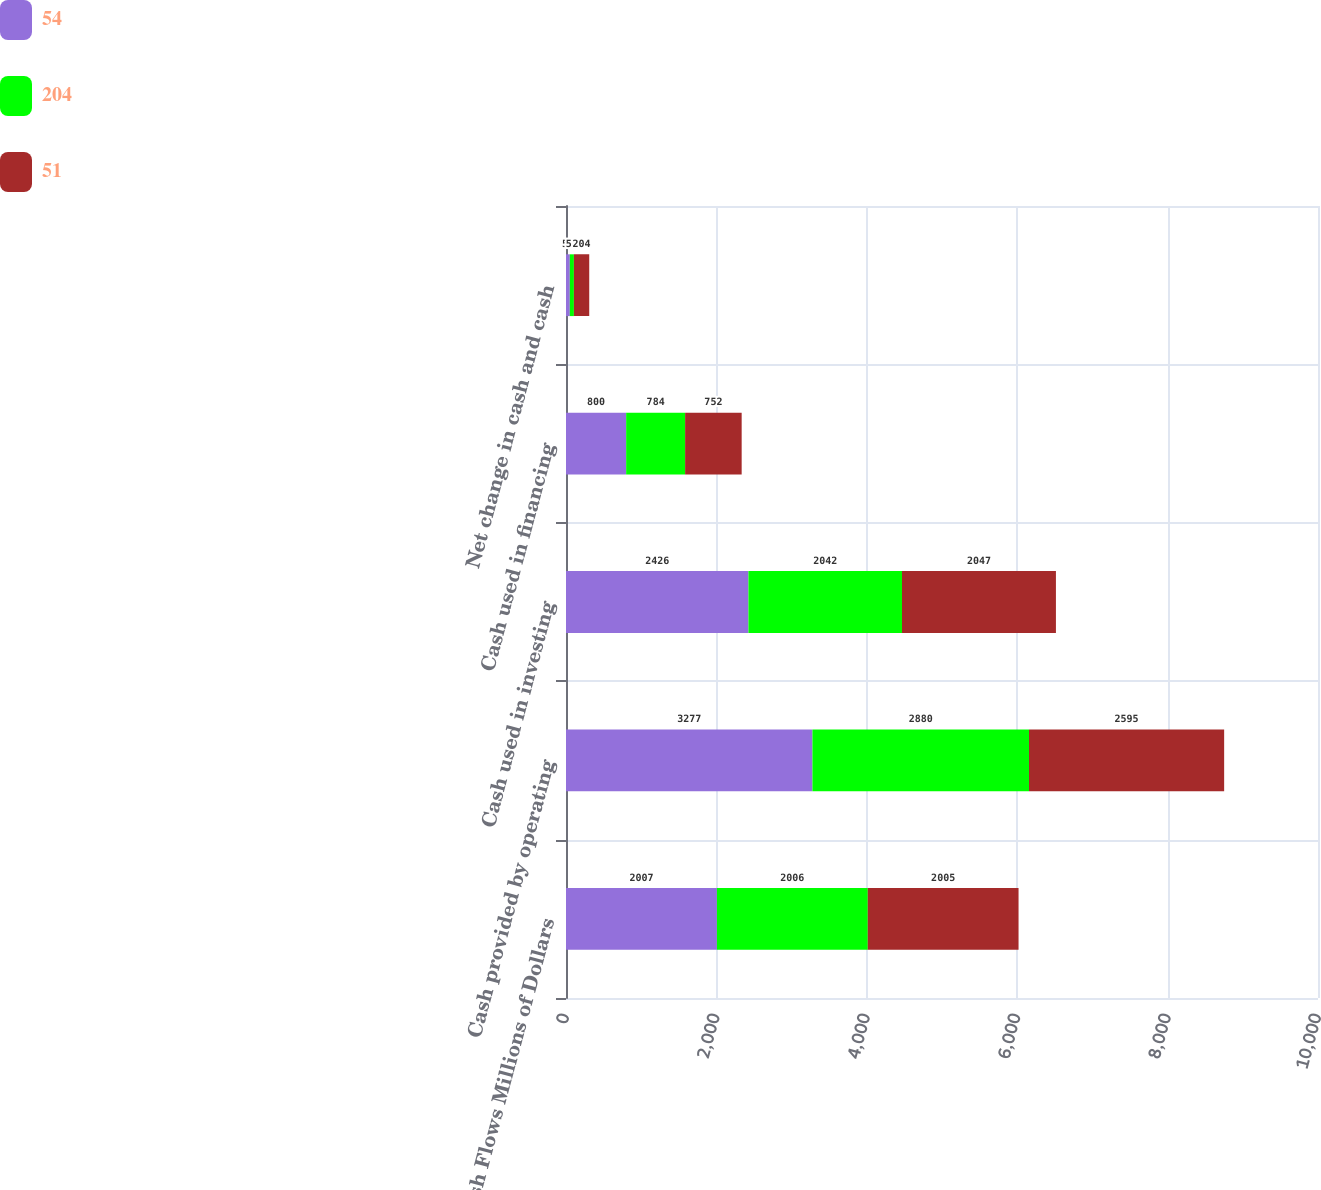Convert chart. <chart><loc_0><loc_0><loc_500><loc_500><stacked_bar_chart><ecel><fcel>Cash Flows Millions of Dollars<fcel>Cash provided by operating<fcel>Cash used in investing<fcel>Cash used in financing<fcel>Net change in cash and cash<nl><fcel>54<fcel>2007<fcel>3277<fcel>2426<fcel>800<fcel>51<nl><fcel>204<fcel>2006<fcel>2880<fcel>2042<fcel>784<fcel>54<nl><fcel>51<fcel>2005<fcel>2595<fcel>2047<fcel>752<fcel>204<nl></chart> 